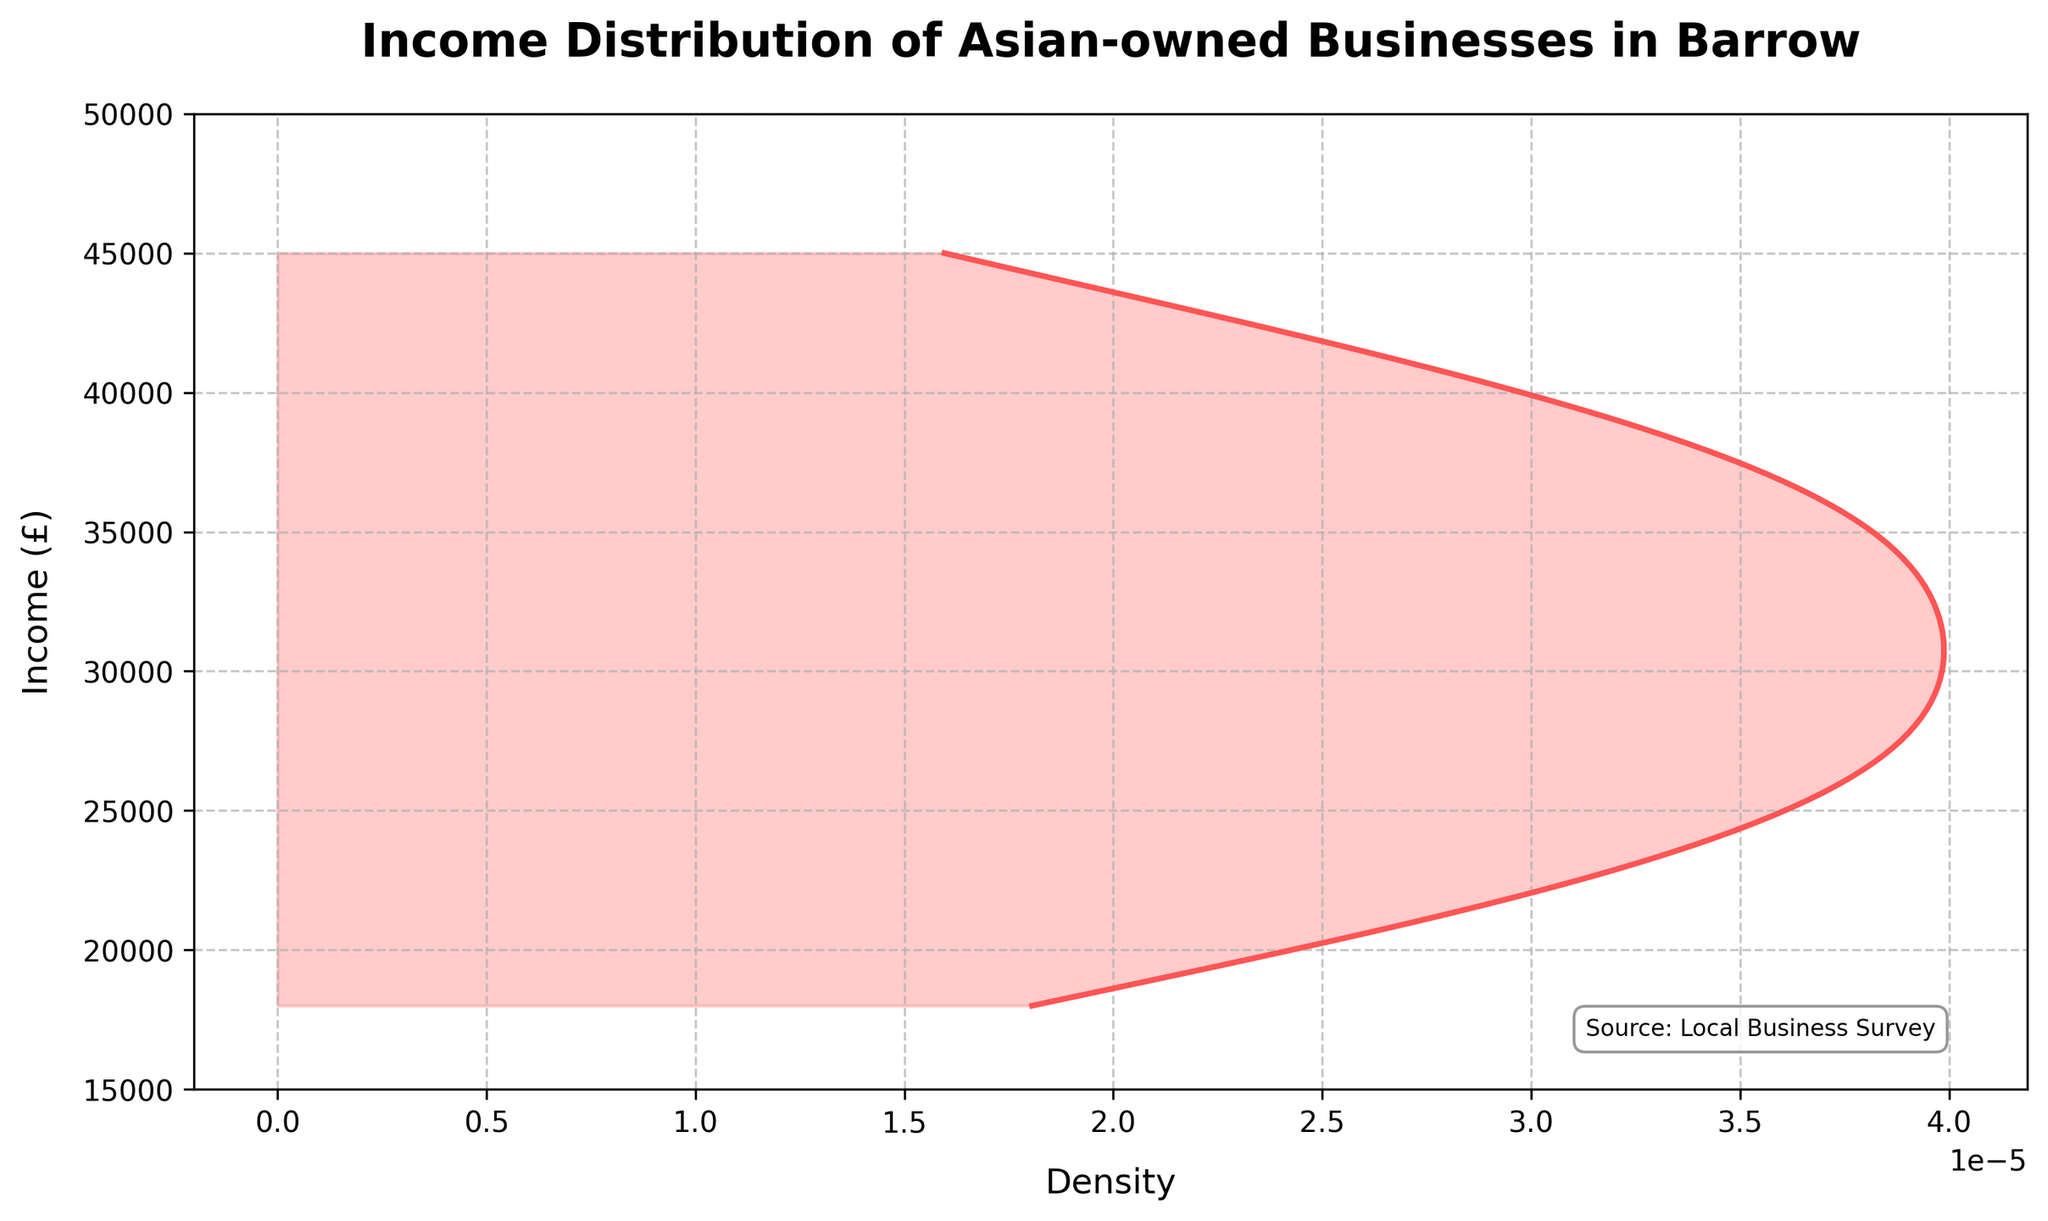What is the title of the plot? The title is a text that usually appears at the top of the plot, summarizing its content. The title is clearly visible and states the main topic of the visualization, which in this case is the "Income Distribution of Asian-owned Businesses in Barrow".
Answer: Income Distribution of Asian-owned Businesses in Barrow What does the x-axis represent? The x-axis in the plot represents the density of the income distribution. This axis typically shows the frequency with which the incomes occur within the dataset, with higher values indicating more common income levels.
Answer: Density What does the y-axis represent? The y-axis in the plot represents the income levels of Asian-owned businesses, measured in pounds (£). The axis scale ranges from £15,000 to £50,000, suggesting this is the income range being analyzed.
Answer: Income (£) What is the source of the data used in the plot? The source of the data is usually mentioned in textual annotations for credibility and reference. In this plot, the source is indicated as "Local Business Survey" at the bottom right of the plot.
Answer: Local Business Survey What income range appears to have the highest density? The highest density can be found by looking at where the density curve (in red) reaches its peak on the plot. The peak of this curve indicates the income range that is most common among the businesses.
Answer: Around £30,000 to £35,000 What approximate income levels show low density? Low density areas are where the density curve is close to zero. By examining the curve, we can identify which income levels are less common.
Answer: Around £15,000 and £45,000 to £50,000 Are there any specific annotations or textual information added to the plot? Observing any additional text added to clarify the data or credit sources is important. In this plot, there is a text annotation at the bottom right, stating the data source as "Local Business Survey".
Answer: Yes, the source information How does the density change between £20,000 and £40,000? This requires observing the density curve within the specified income range. By following the curve from £20,000 to £40,000, we note that the density increases, peaks around £30,000 to £35,000, and then decreases.
Answer: Increases and then decreases Is the income distribution symmetrical? Symmetry in distribution indicates the curve is a mirror image on both sides of the peak. In this plot, we observe that the density curve rises and falls but is not symmetrical around its peak.
Answer: No What is the approximate income level at the highest density point? To find this, locate the peak of the density curve and refer to the corresponding y-axis value. By visual inspection, the peak appears around £32,000 to £35,000.
Answer: Approximately £32,000 to £35,000 